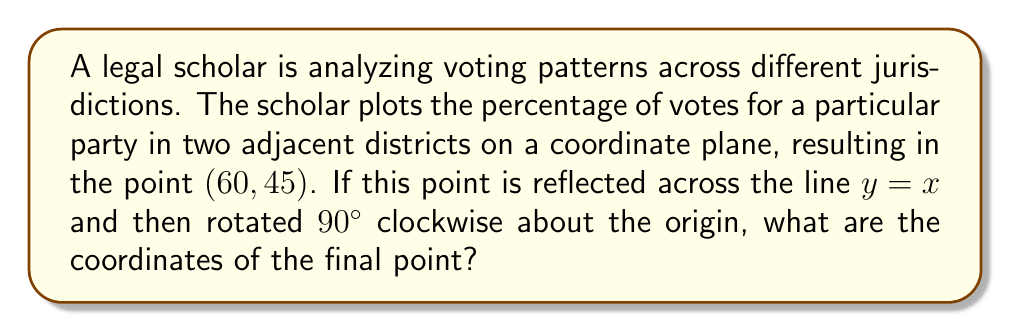Can you answer this question? Let's approach this step-by-step:

1) The initial point is (60, 45).

2) Reflection across y = x:
   - To reflect a point (a, b) across y = x, we swap its coordinates to (b, a).
   - So (60, 45) becomes (45, 60).

3) Rotation 90° clockwise about the origin:
   - For a 90° clockwise rotation, we use the formula (x, y) → (y, -x).
   - So (45, 60) becomes (60, -45).

Therefore, the final coordinates are (60, -45).

This can be represented mathematically as:

$$(x, y) \xrightarrow{\text{reflect}} (y, x) \xrightarrow{\text{rotate}} (x, -y)$$

$$(60, 45) \xrightarrow{\text{reflect}} (45, 60) \xrightarrow{\text{rotate}} (60, -45)$$
Answer: (60, -45) 